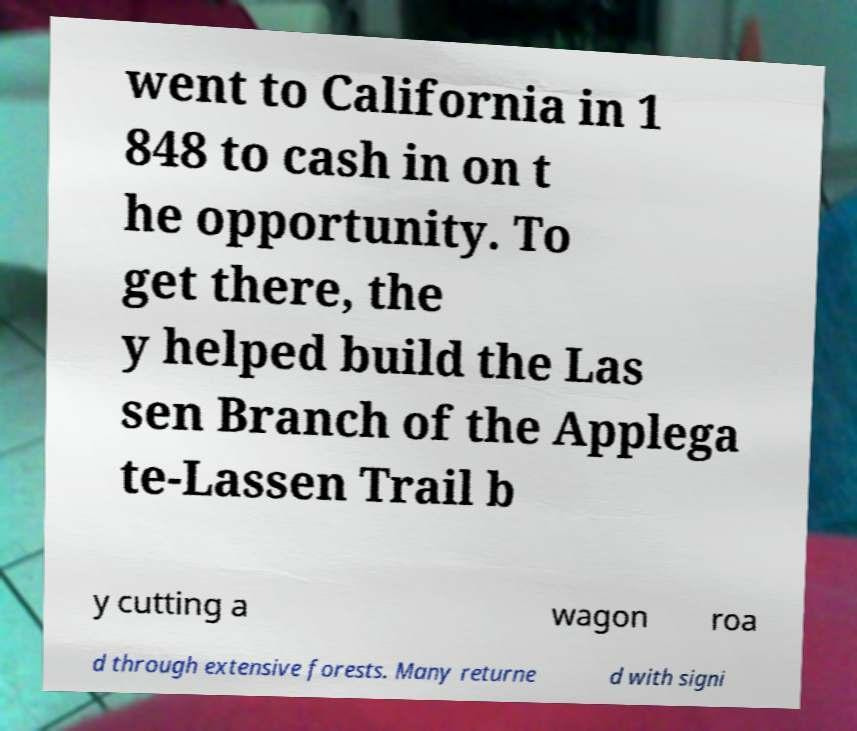Could you assist in decoding the text presented in this image and type it out clearly? went to California in 1 848 to cash in on t he opportunity. To get there, the y helped build the Las sen Branch of the Applega te-Lassen Trail b y cutting a wagon roa d through extensive forests. Many returne d with signi 